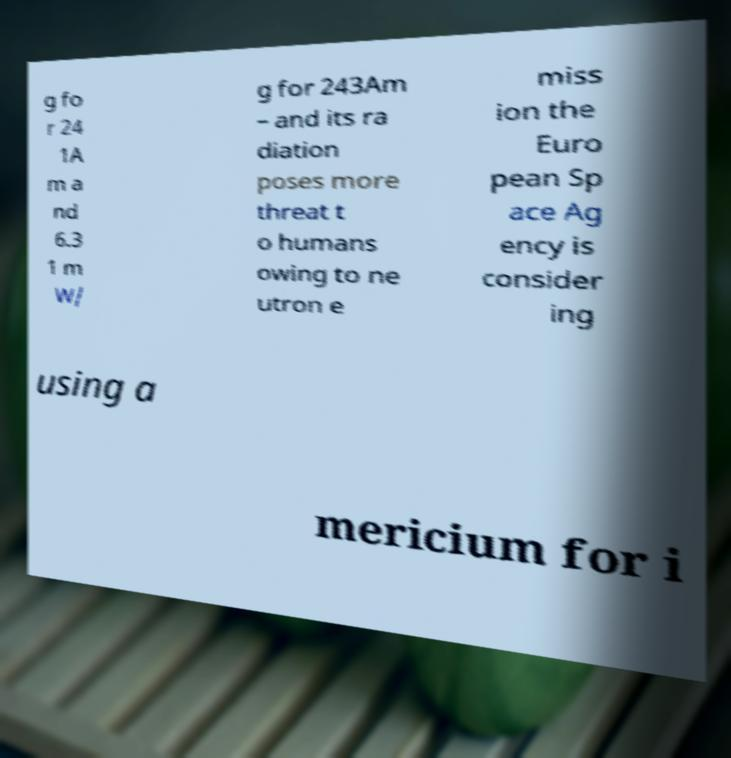There's text embedded in this image that I need extracted. Can you transcribe it verbatim? g fo r 24 1A m a nd 6.3 1 m W/ g for 243Am – and its ra diation poses more threat t o humans owing to ne utron e miss ion the Euro pean Sp ace Ag ency is consider ing using a mericium for i 